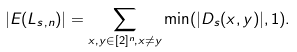Convert formula to latex. <formula><loc_0><loc_0><loc_500><loc_500>| E ( L _ { s , n } ) | = \sum _ { x , y \in [ 2 ] ^ { n } , x \neq y } \min ( | D _ { s } ( x , y ) | , 1 ) .</formula> 